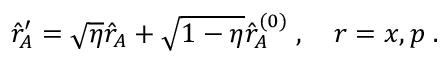<formula> <loc_0><loc_0><loc_500><loc_500>\begin{array} { r } { \hat { r } _ { A } ^ { \prime } = \sqrt { \eta } \hat { r } _ { A } + \sqrt { 1 - \eta } \hat { r } _ { A } ^ { ( 0 ) } \, , \quad r = x , p \, . } \end{array}</formula> 